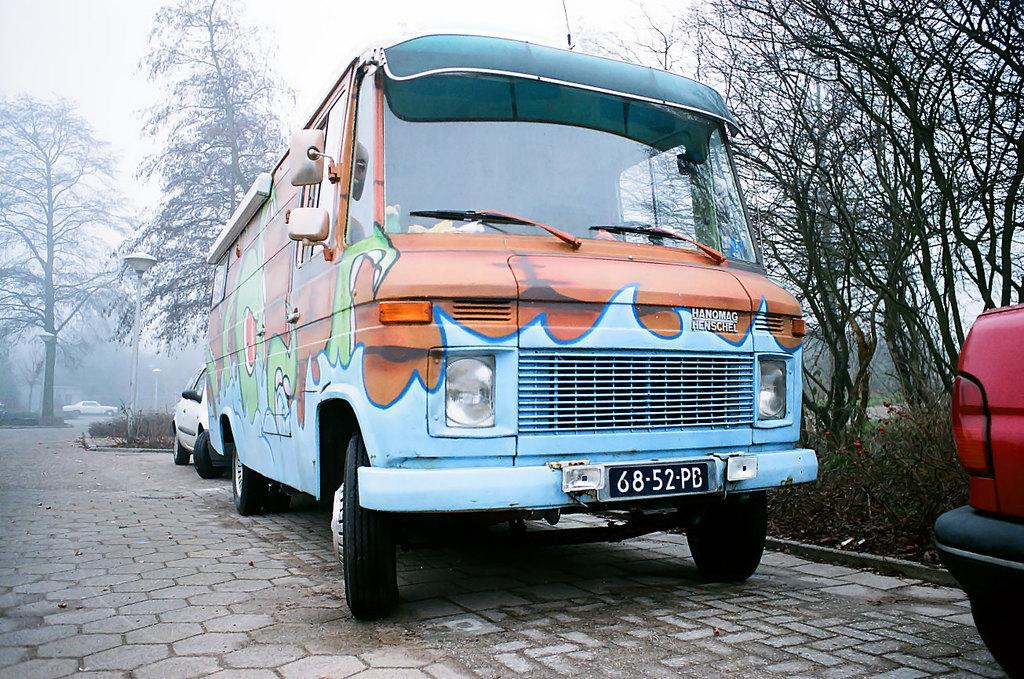<image>
Relay a brief, clear account of the picture shown. An old school bus painted light blue with a orange and green design on it. 